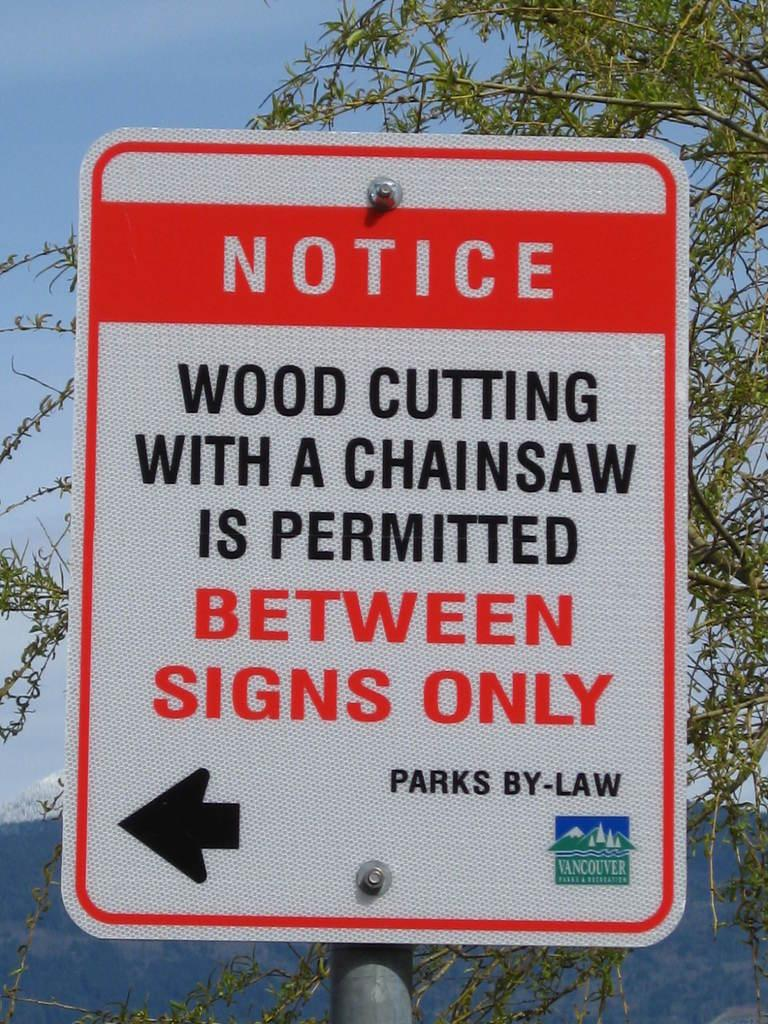<image>
Provide a brief description of the given image. A sign tells people that wood cutting with a chainsaw is permitted only between the signs. 